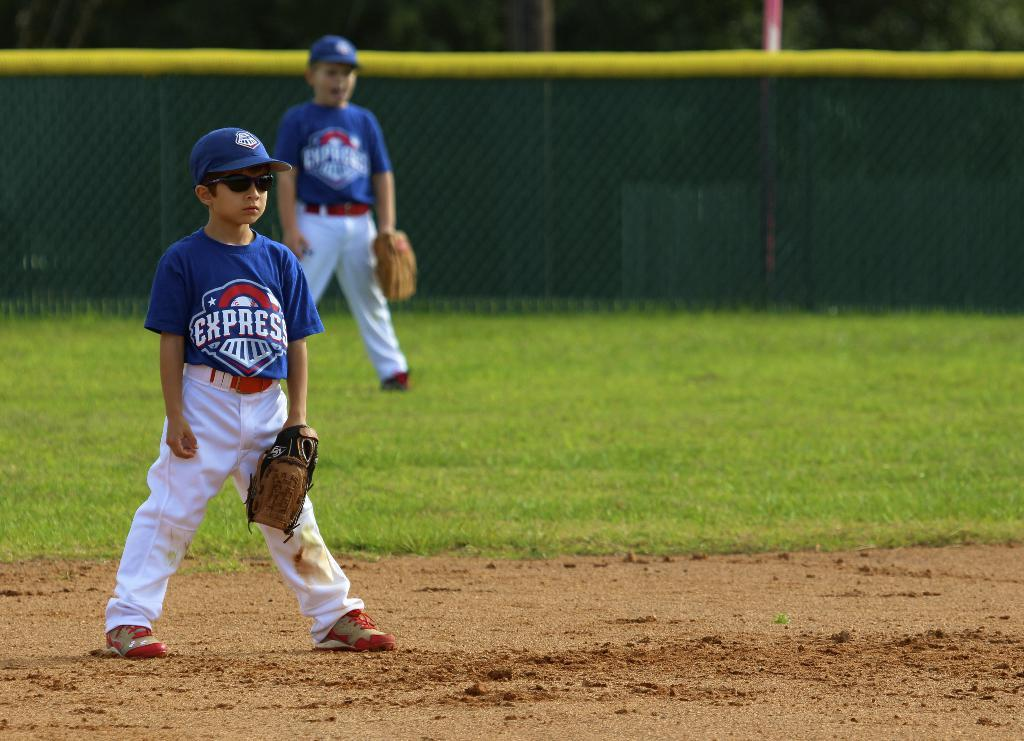<image>
Provide a brief description of the given image. The two kids on the baseball field are wearing Express jerseys 